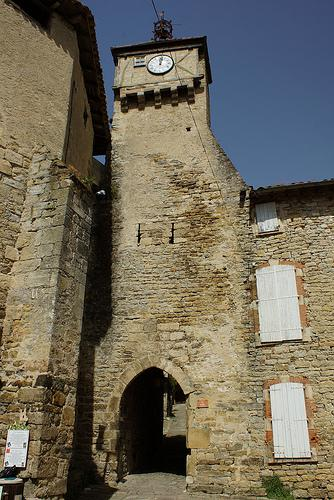Question: where was this photo taken?
Choices:
A. At a medieval tower.
B. At the beach.
C. In the forest.
D. In the field.
Answer with the letter. Answer: A Question: why did the Vikings build the tower?
Choices:
A. For defense.
B. For warmth.
C. As a lookout station.
D. For science.
Answer with the letter. Answer: C Question: what is at the top of the tower?
Choices:
A. A clock.
B. A weather vane.
C. A bird.
D. A cupola.
Answer with the letter. Answer: A Question: what is covering the windows?
Choices:
A. Curtains.
B. Shutters.
C. Blinds.
D. Frost.
Answer with the letter. Answer: B 